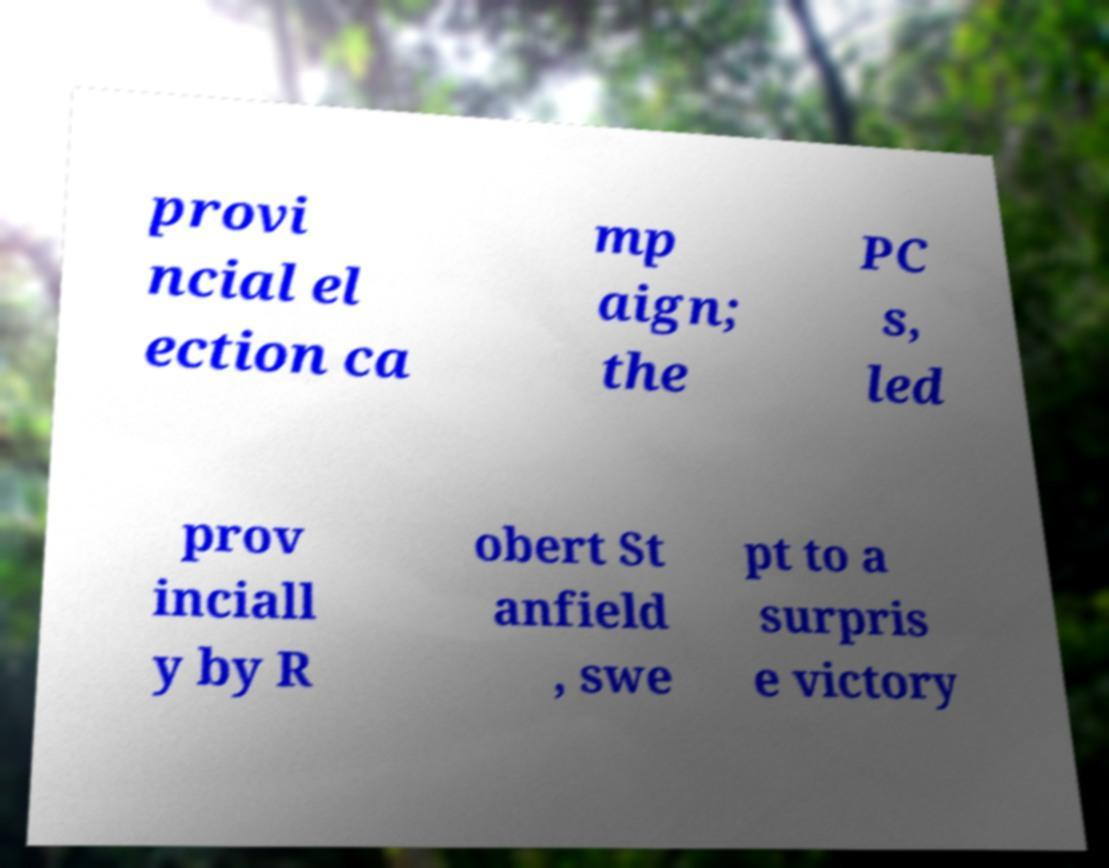Please read and relay the text visible in this image. What does it say? provi ncial el ection ca mp aign; the PC s, led prov inciall y by R obert St anfield , swe pt to a surpris e victory 